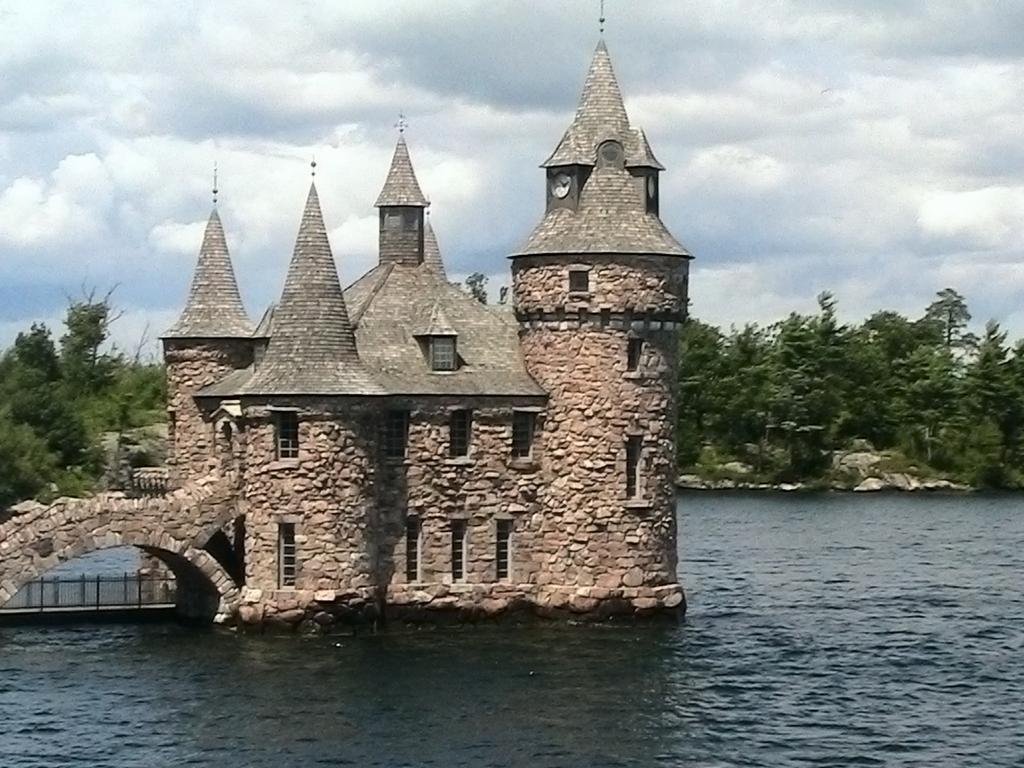Can you describe this image briefly? In this picture there is a building in the foreground, there are trees in the back ground, the sky is at the top and the water is at the bottom 